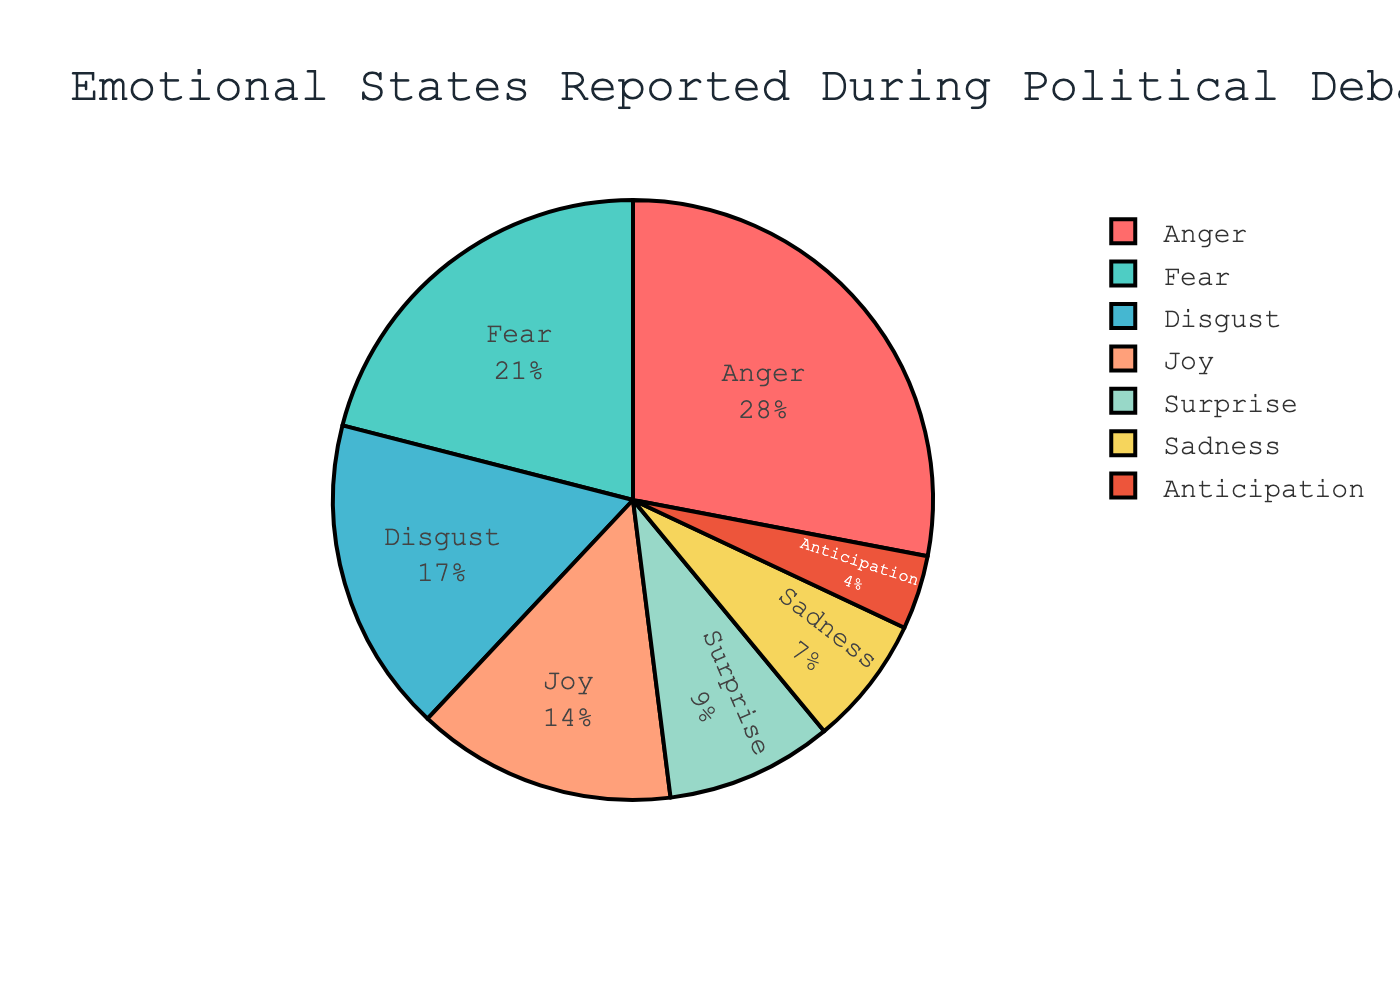What's the most frequently reported emotion during political debates? Looking at the pie chart, the largest segment represents Anger with 28%, making it the most frequently reported emotion.
Answer: Anger Which emotion is just below Anger in terms of frequency? Observing the pie chart, the next largest segment after the 28% Anger segment is the Fear segment, which accounts for 21%.
Answer: Fear What is the combined percentage of negative emotions (Anger, Fear, Disgust, and Sadness)? Summing up the percentages for Anger (28%), Fear (21%), Disgust (17%), and Sadness (7%), we get 28 + 21 + 17 + 7 = 73%.
Answer: 73% Is the percentage of Joy higher than that of Surprise? By comparing the segments, Joy (14%) is indeed higher than Surprise (9%).
Answer: Yes Which emotion has the smallest reported percentage during political debates? The smallest segment in the pie chart corresponds to Anticipation with 4%.
Answer: Anticipation What is the difference in reported percentage between Disgust and Sadness? The Disgust segment is 17%, while the Sadness segment is 7%. The difference is 17 - 7 = 10%.
Answer: 10% How does the percentage of Anger compare to the combined percentage of Anticipation and Surprise? Anger is 28%, while Anticipation is 4% and Surprise is 9%. Summing Anticipation and Surprise gives 4 + 9 = 13%. Therefore, Anger (28%) is greater than the combined Anticipation and Surprise (13%).
Answer: Anger is greater Which emotions combined account for over half of the reported emotions? Adding the percentages of Anger (28%), Fear (21%), and Disgust (17%) gives us 28 + 21 + 17 = 66%, which is over half.
Answer: Anger, Fear, Disgust What is the average percentage of Joy, Surprise, and Anticipation? Adding the percentages of Joy (14%), Surprise (9%), and Anticipation (4%) gives us 14 + 9 + 4 = 27%. Dividing by 3, the average is 27 / 3 = 9%.
Answer: 9% What color represents the 'Disgust' emotion in the pie chart? Based on the colors mentioned: Anger is red (#FF6B6B), Fear is teal (#4ECDC4), Disgust is blue (#45B7D1), Joy is peach (#FFA07A), Surprise is light green (#98D8C8), Sadness is yellow (#F6D55C), and Anticipation is orange (#ED553B). Thus, Disgust is represented by blue.
Answer: Blue 